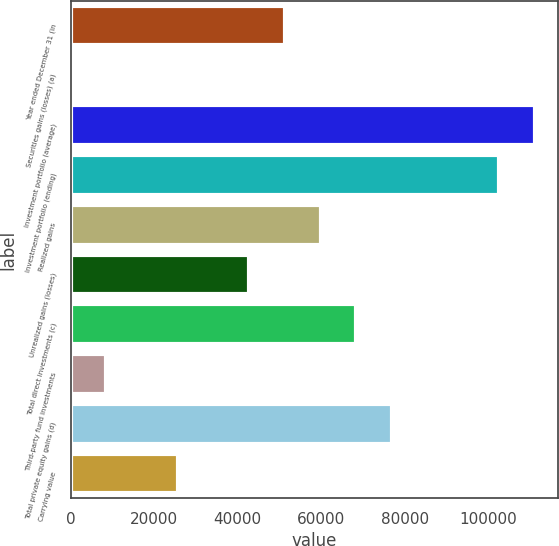<chart> <loc_0><loc_0><loc_500><loc_500><bar_chart><fcel>Year ended December 31 (in<fcel>Securities gains (losses) (a)<fcel>Investment portfolio (average)<fcel>Investment portfolio (ending)<fcel>Realized gains<fcel>Unrealized gains (losses)<fcel>Total direct investments (c)<fcel>Third-party fund investments<fcel>Total private equity gains (d)<fcel>Carrying value<nl><fcel>51325<fcel>37<fcel>111161<fcel>102613<fcel>59873<fcel>42777<fcel>68421<fcel>8585<fcel>76969<fcel>25681<nl></chart> 